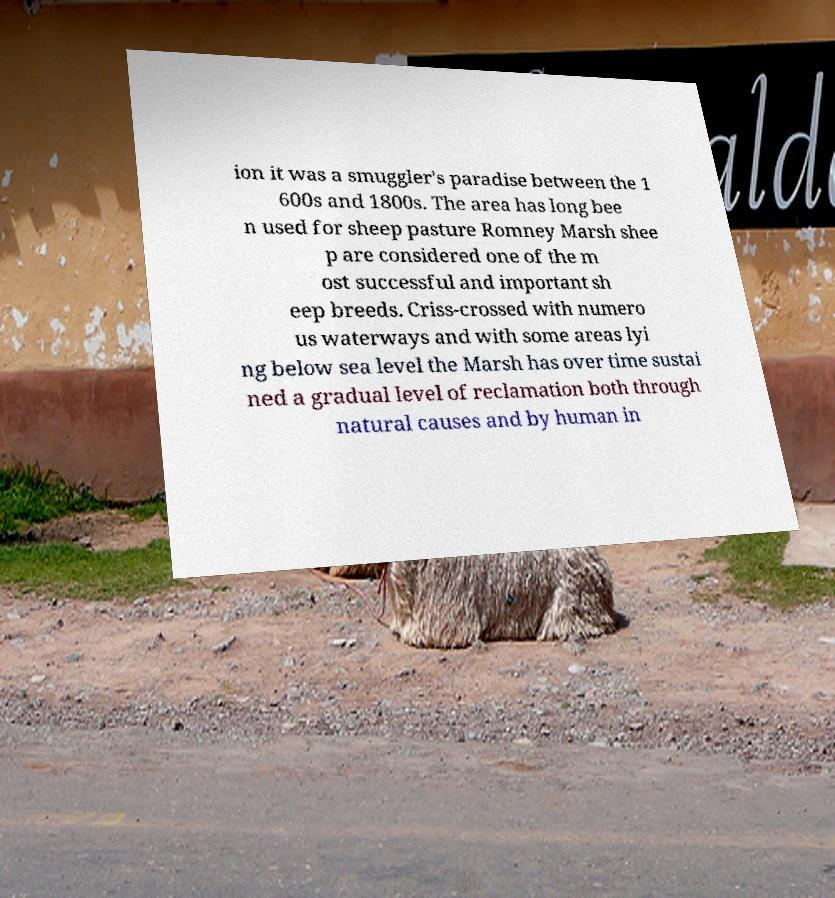Please identify and transcribe the text found in this image. ion it was a smuggler's paradise between the 1 600s and 1800s. The area has long bee n used for sheep pasture Romney Marsh shee p are considered one of the m ost successful and important sh eep breeds. Criss-crossed with numero us waterways and with some areas lyi ng below sea level the Marsh has over time sustai ned a gradual level of reclamation both through natural causes and by human in 